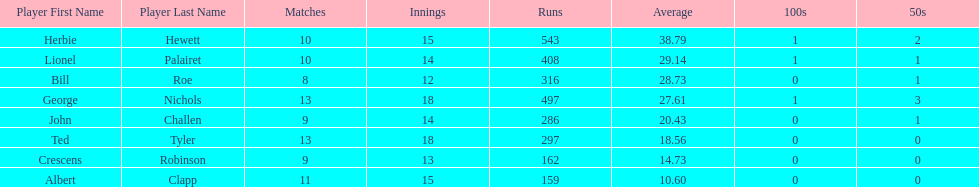How many runs did ted tyler have? 297. 